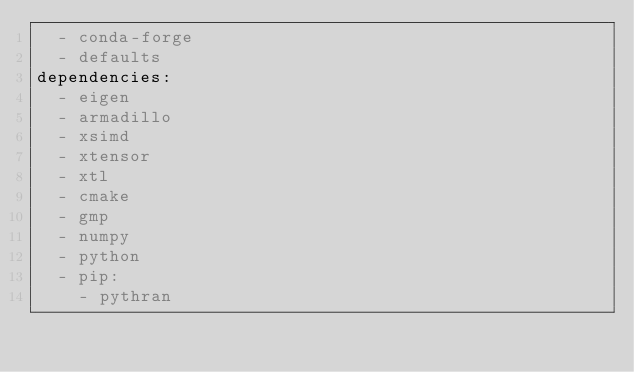<code> <loc_0><loc_0><loc_500><loc_500><_YAML_>  - conda-forge
  - defaults
dependencies:
  - eigen
  - armadillo
  - xsimd
  - xtensor
  - xtl
  - cmake
  - gmp
  - numpy
  - python
  - pip:
    - pythran
</code> 